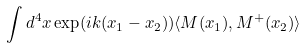Convert formula to latex. <formula><loc_0><loc_0><loc_500><loc_500>\int d ^ { 4 } x \exp ( i k ( x _ { 1 } - x _ { 2 } ) ) \langle M ( x _ { 1 } ) , M ^ { + } ( x _ { 2 } ) \rangle</formula> 